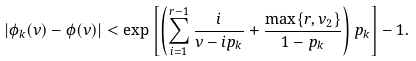Convert formula to latex. <formula><loc_0><loc_0><loc_500><loc_500>| \phi _ { k } ( \nu ) - \phi ( \nu ) | < \exp \left [ \left ( \sum _ { i = 1 } ^ { r - 1 } \frac { i } { \nu - i p _ { k } } + \frac { \max \{ r , \nu _ { 2 } \} } { 1 - p _ { k } } \right ) p _ { k } \right ] - 1 .</formula> 